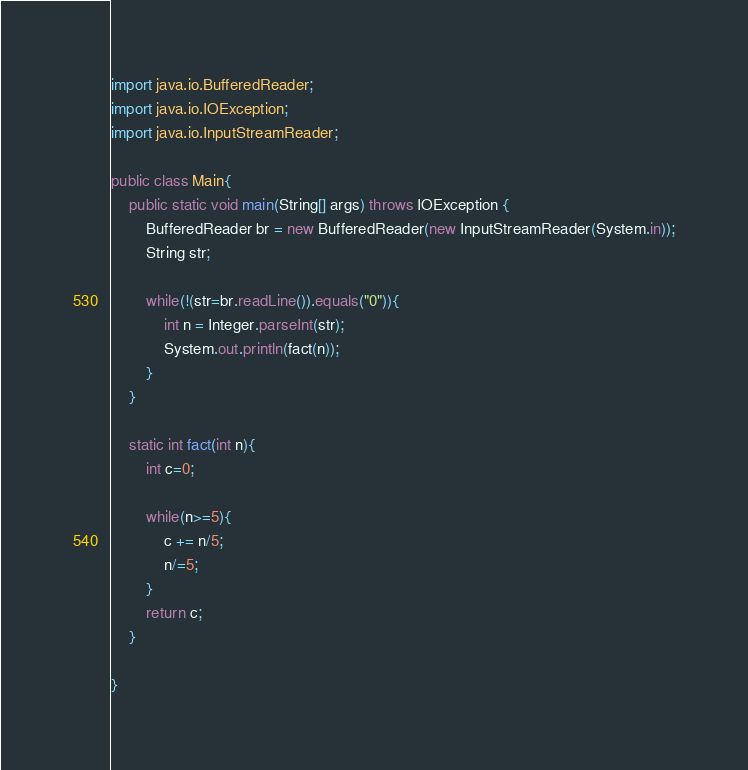Convert code to text. <code><loc_0><loc_0><loc_500><loc_500><_Java_>import java.io.BufferedReader;
import java.io.IOException;
import java.io.InputStreamReader;

public class Main{
	public static void main(String[] args) throws IOException {
		BufferedReader br = new BufferedReader(new InputStreamReader(System.in));
		String str;

		while(!(str=br.readLine()).equals("0")){
			int n = Integer.parseInt(str);
			System.out.println(fact(n));
		}
	}

	static int fact(int n){
		int c=0;

		while(n>=5){
			c += n/5;
			n/=5;
		}
		return c;
	}

}</code> 